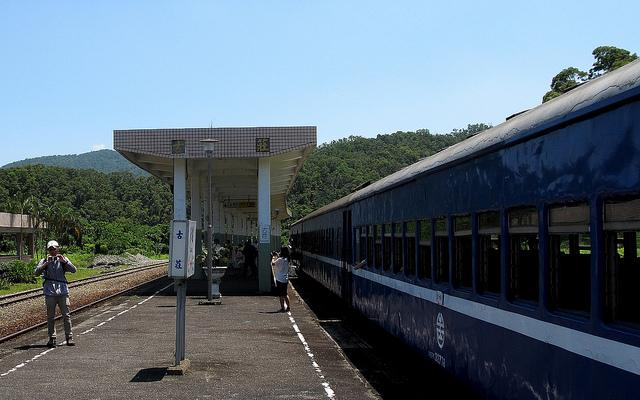Who is sheltered here? Please explain your reasoning. train riders. Most train stations have a roof so the riders won't get wet while waiting. 